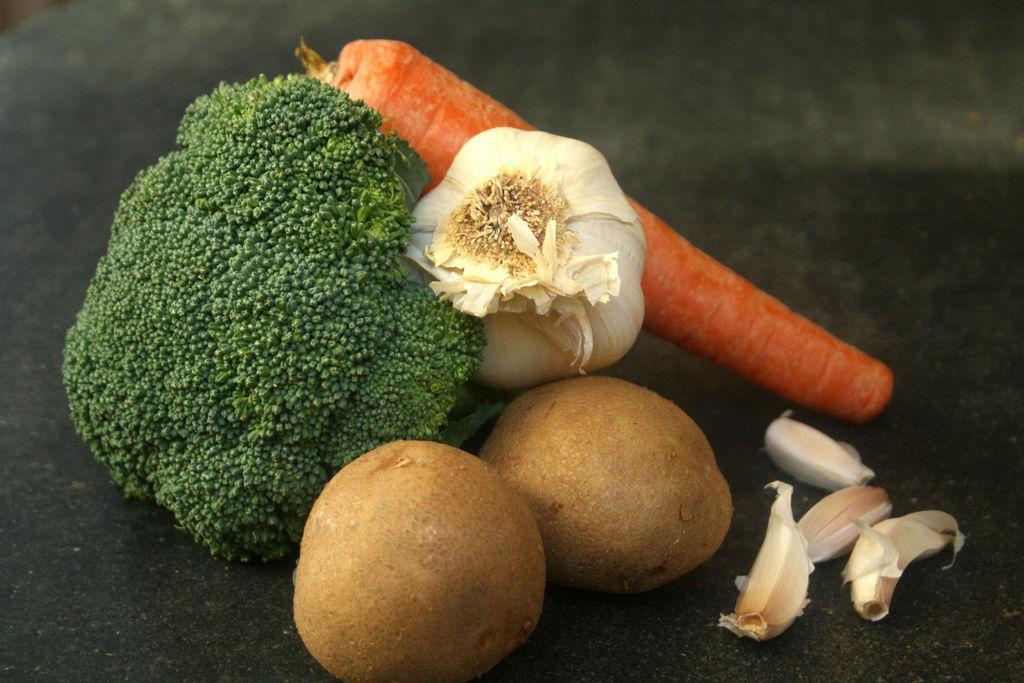How would you summarize this image in a sentence or two? In this image we can see some fruits and vegetables. 